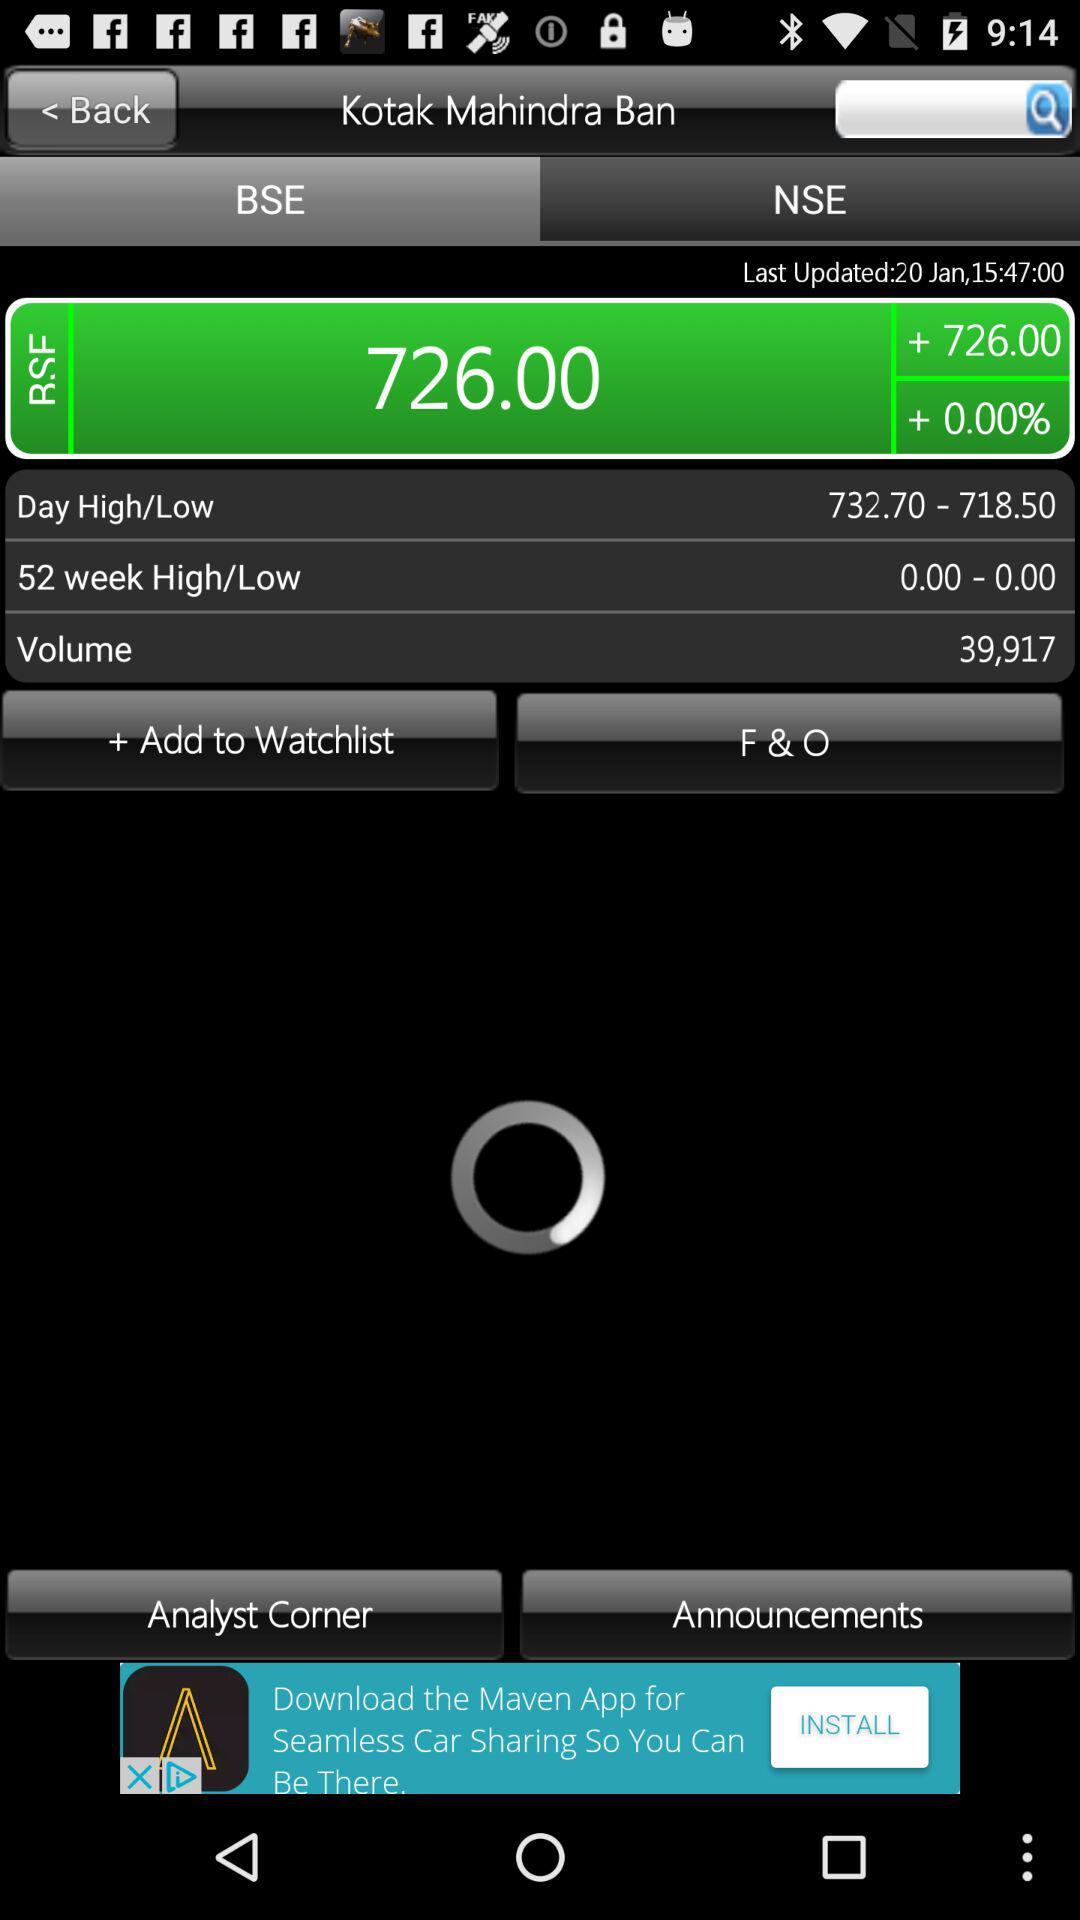Which tab is selected? The selected tab is "BSE". 